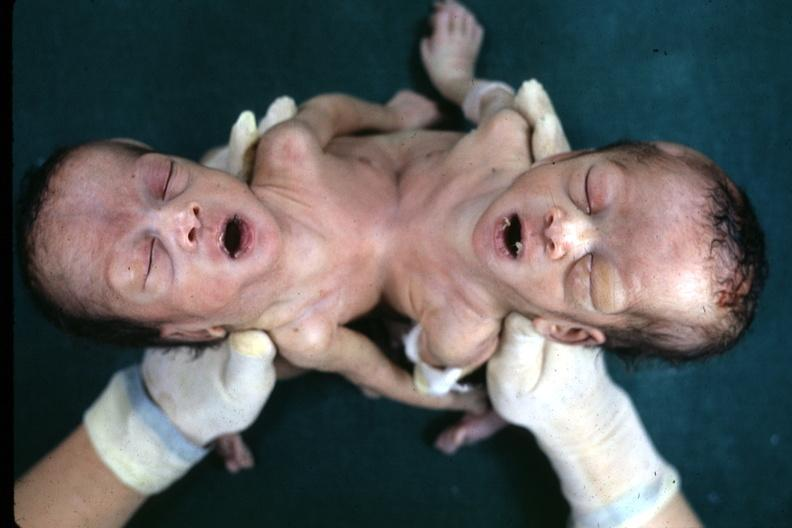what is view looking down on heads joined?
Answer the question using a single word or phrase. Lower chest and abdomen 